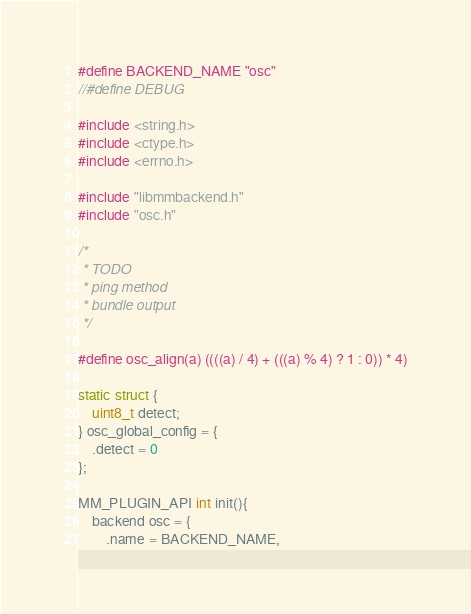Convert code to text. <code><loc_0><loc_0><loc_500><loc_500><_C_>#define BACKEND_NAME "osc"
//#define DEBUG

#include <string.h>
#include <ctype.h>
#include <errno.h>

#include "libmmbackend.h"
#include "osc.h"

/*
 * TODO
 * ping method
 * bundle output
 */

#define osc_align(a) ((((a) / 4) + (((a) % 4) ? 1 : 0)) * 4)

static struct {
	uint8_t detect;
} osc_global_config = {
	.detect = 0
};

MM_PLUGIN_API int init(){
	backend osc = {
		.name = BACKEND_NAME,</code> 